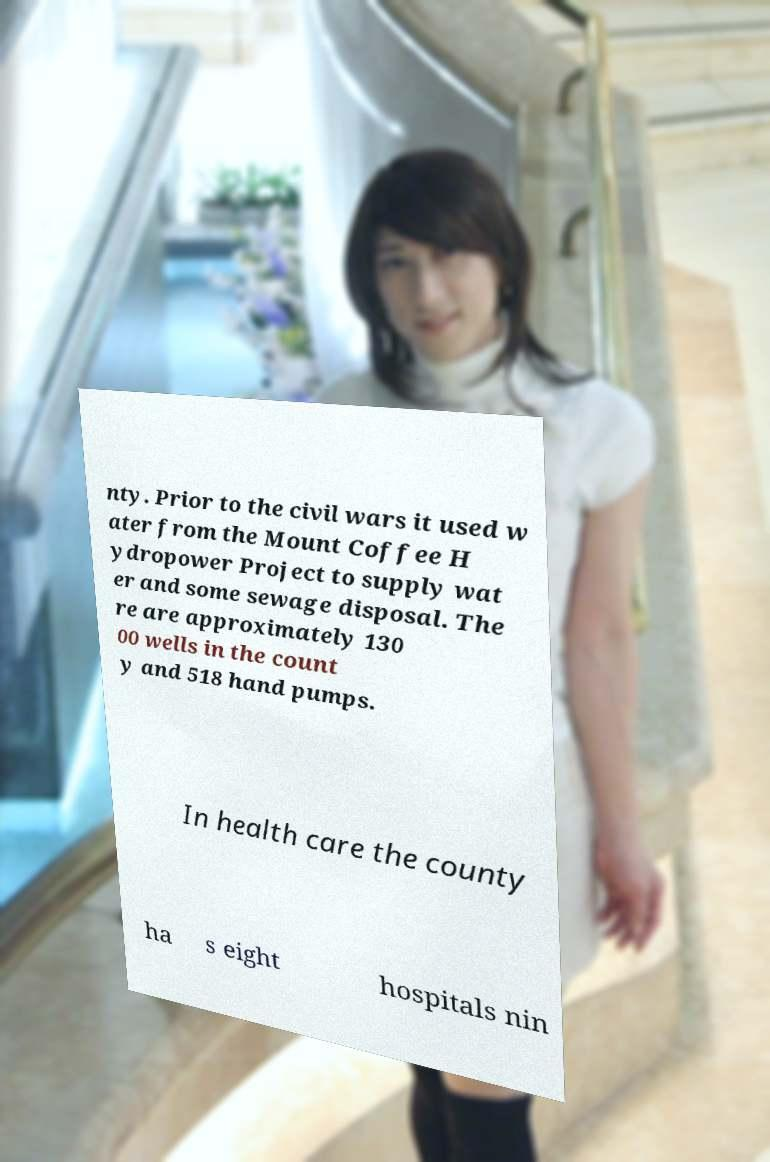Can you read and provide the text displayed in the image?This photo seems to have some interesting text. Can you extract and type it out for me? nty. Prior to the civil wars it used w ater from the Mount Coffee H ydropower Project to supply wat er and some sewage disposal. The re are approximately 130 00 wells in the count y and 518 hand pumps. In health care the county ha s eight hospitals nin 